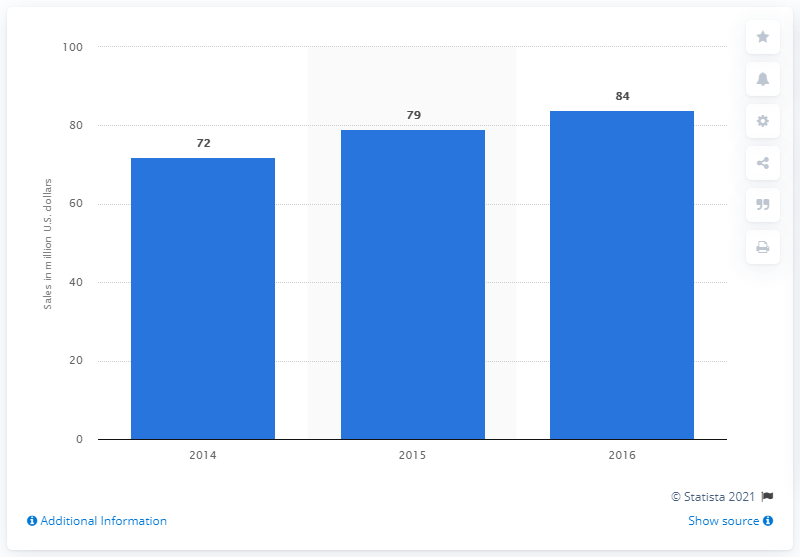Give some essential details in this illustration. In 2016, the value of MaidPro's franchise sales in the United States was $84 million. 